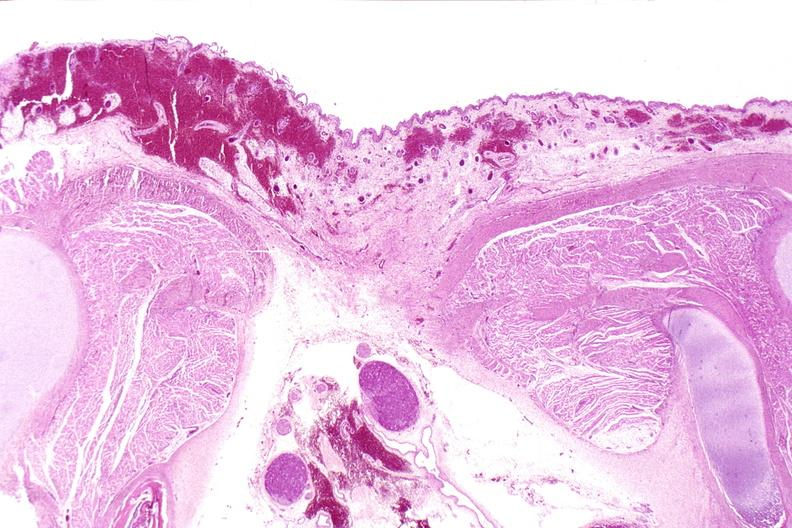s matting history of this case present?
Answer the question using a single word or phrase. No 